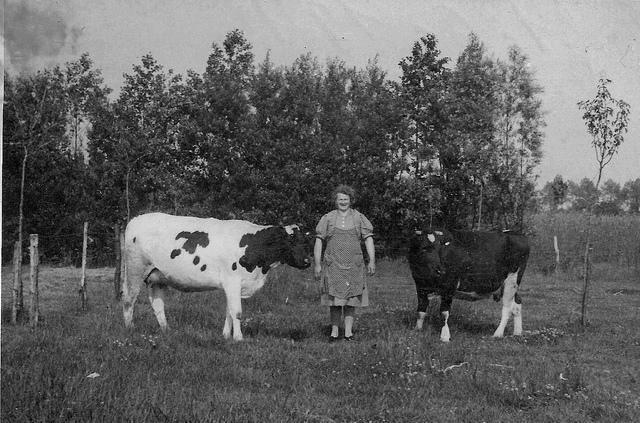How many legs are there?
Give a very brief answer. 10. How many cows are there?
Give a very brief answer. 2. How many cows are in the picture?
Give a very brief answer. 2. 